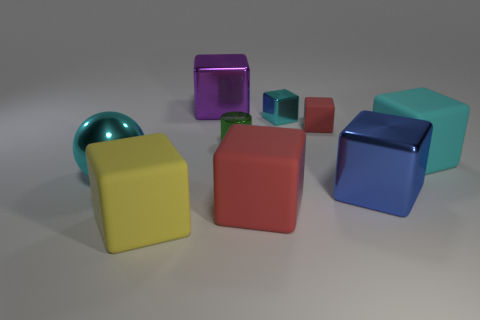Subtract all big cyan matte blocks. How many blocks are left? 6 Subtract all cyan cubes. How many cubes are left? 5 Subtract all cyan cylinders. How many red blocks are left? 2 Add 1 gray objects. How many objects exist? 10 Subtract 3 cubes. How many cubes are left? 4 Subtract all brown cubes. Subtract all purple cylinders. How many cubes are left? 7 Subtract all cylinders. How many objects are left? 8 Subtract all tiny shiny objects. Subtract all tiny rubber cubes. How many objects are left? 6 Add 4 balls. How many balls are left? 5 Add 6 yellow shiny objects. How many yellow shiny objects exist? 6 